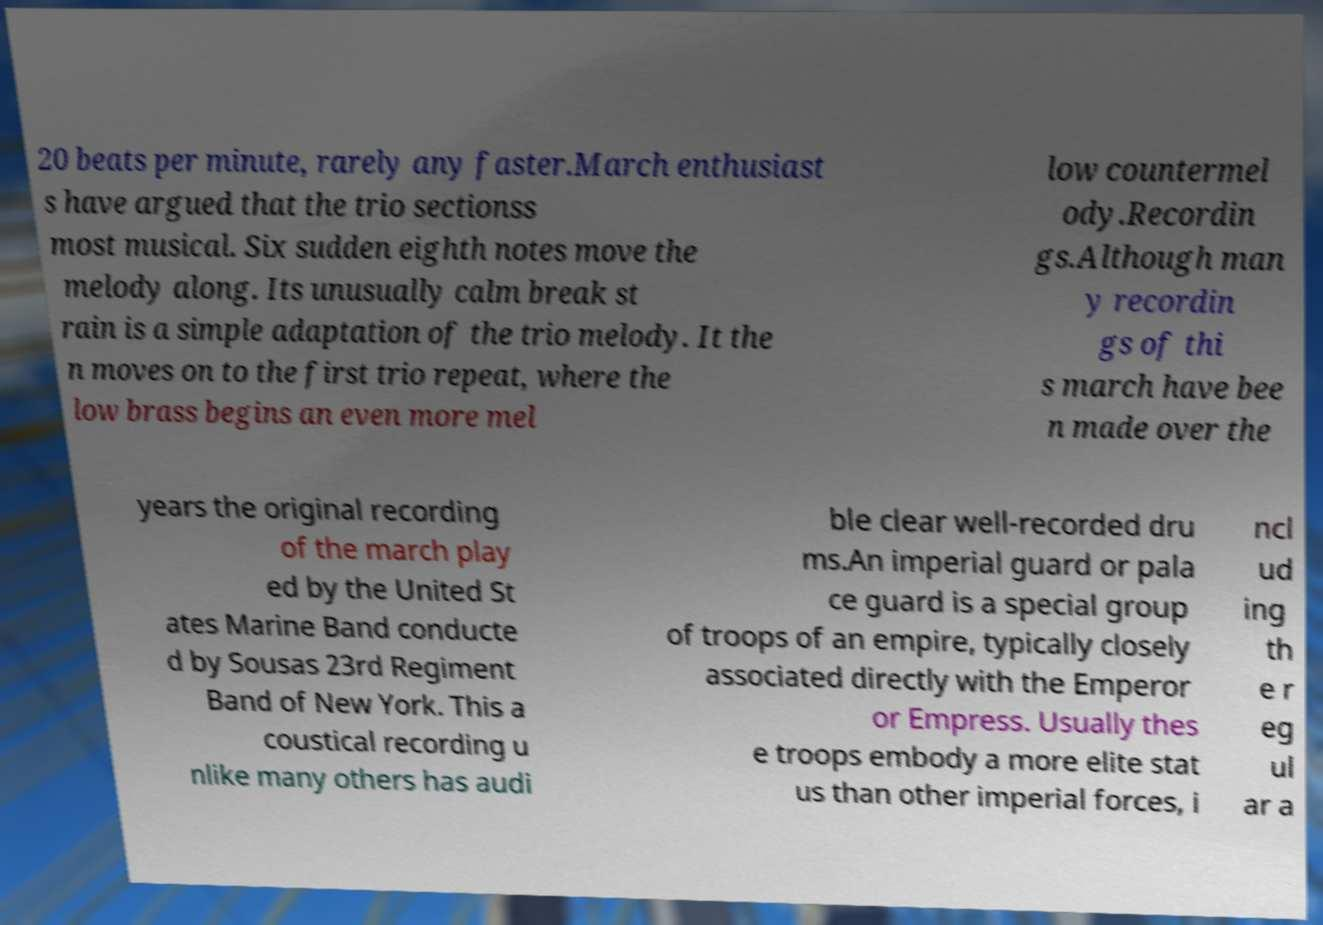Please read and relay the text visible in this image. What does it say? 20 beats per minute, rarely any faster.March enthusiast s have argued that the trio sectionss most musical. Six sudden eighth notes move the melody along. Its unusually calm break st rain is a simple adaptation of the trio melody. It the n moves on to the first trio repeat, where the low brass begins an even more mel low countermel ody.Recordin gs.Although man y recordin gs of thi s march have bee n made over the years the original recording of the march play ed by the United St ates Marine Band conducte d by Sousas 23rd Regiment Band of New York. This a coustical recording u nlike many others has audi ble clear well-recorded dru ms.An imperial guard or pala ce guard is a special group of troops of an empire, typically closely associated directly with the Emperor or Empress. Usually thes e troops embody a more elite stat us than other imperial forces, i ncl ud ing th e r eg ul ar a 